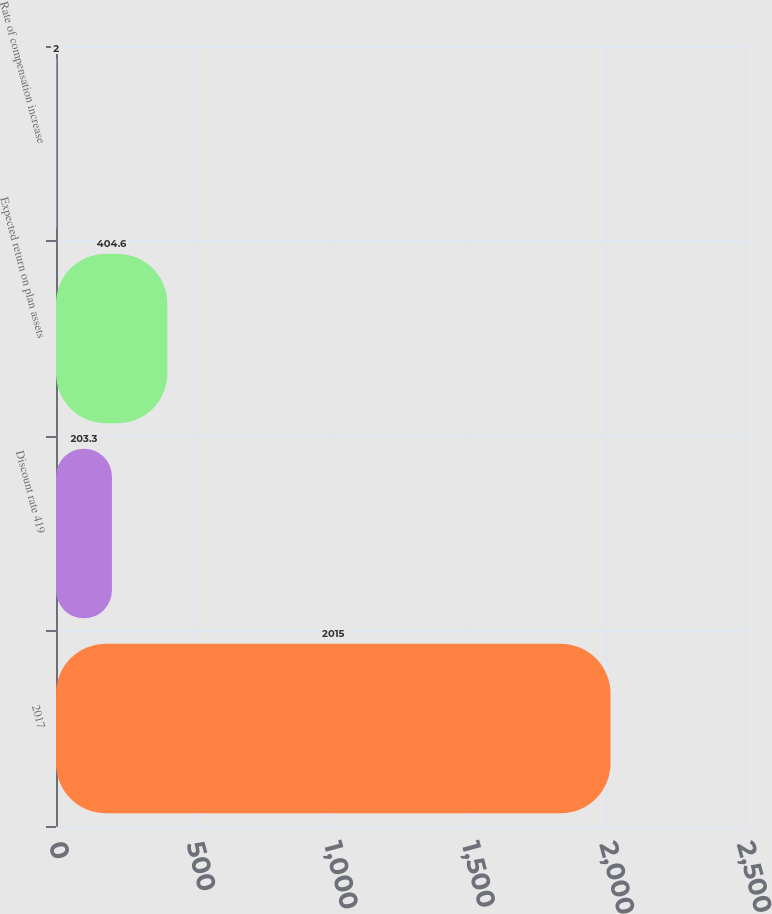Convert chart. <chart><loc_0><loc_0><loc_500><loc_500><bar_chart><fcel>2017<fcel>Discount rate 419<fcel>Expected return on plan assets<fcel>Rate of compensation increase<nl><fcel>2015<fcel>203.3<fcel>404.6<fcel>2<nl></chart> 